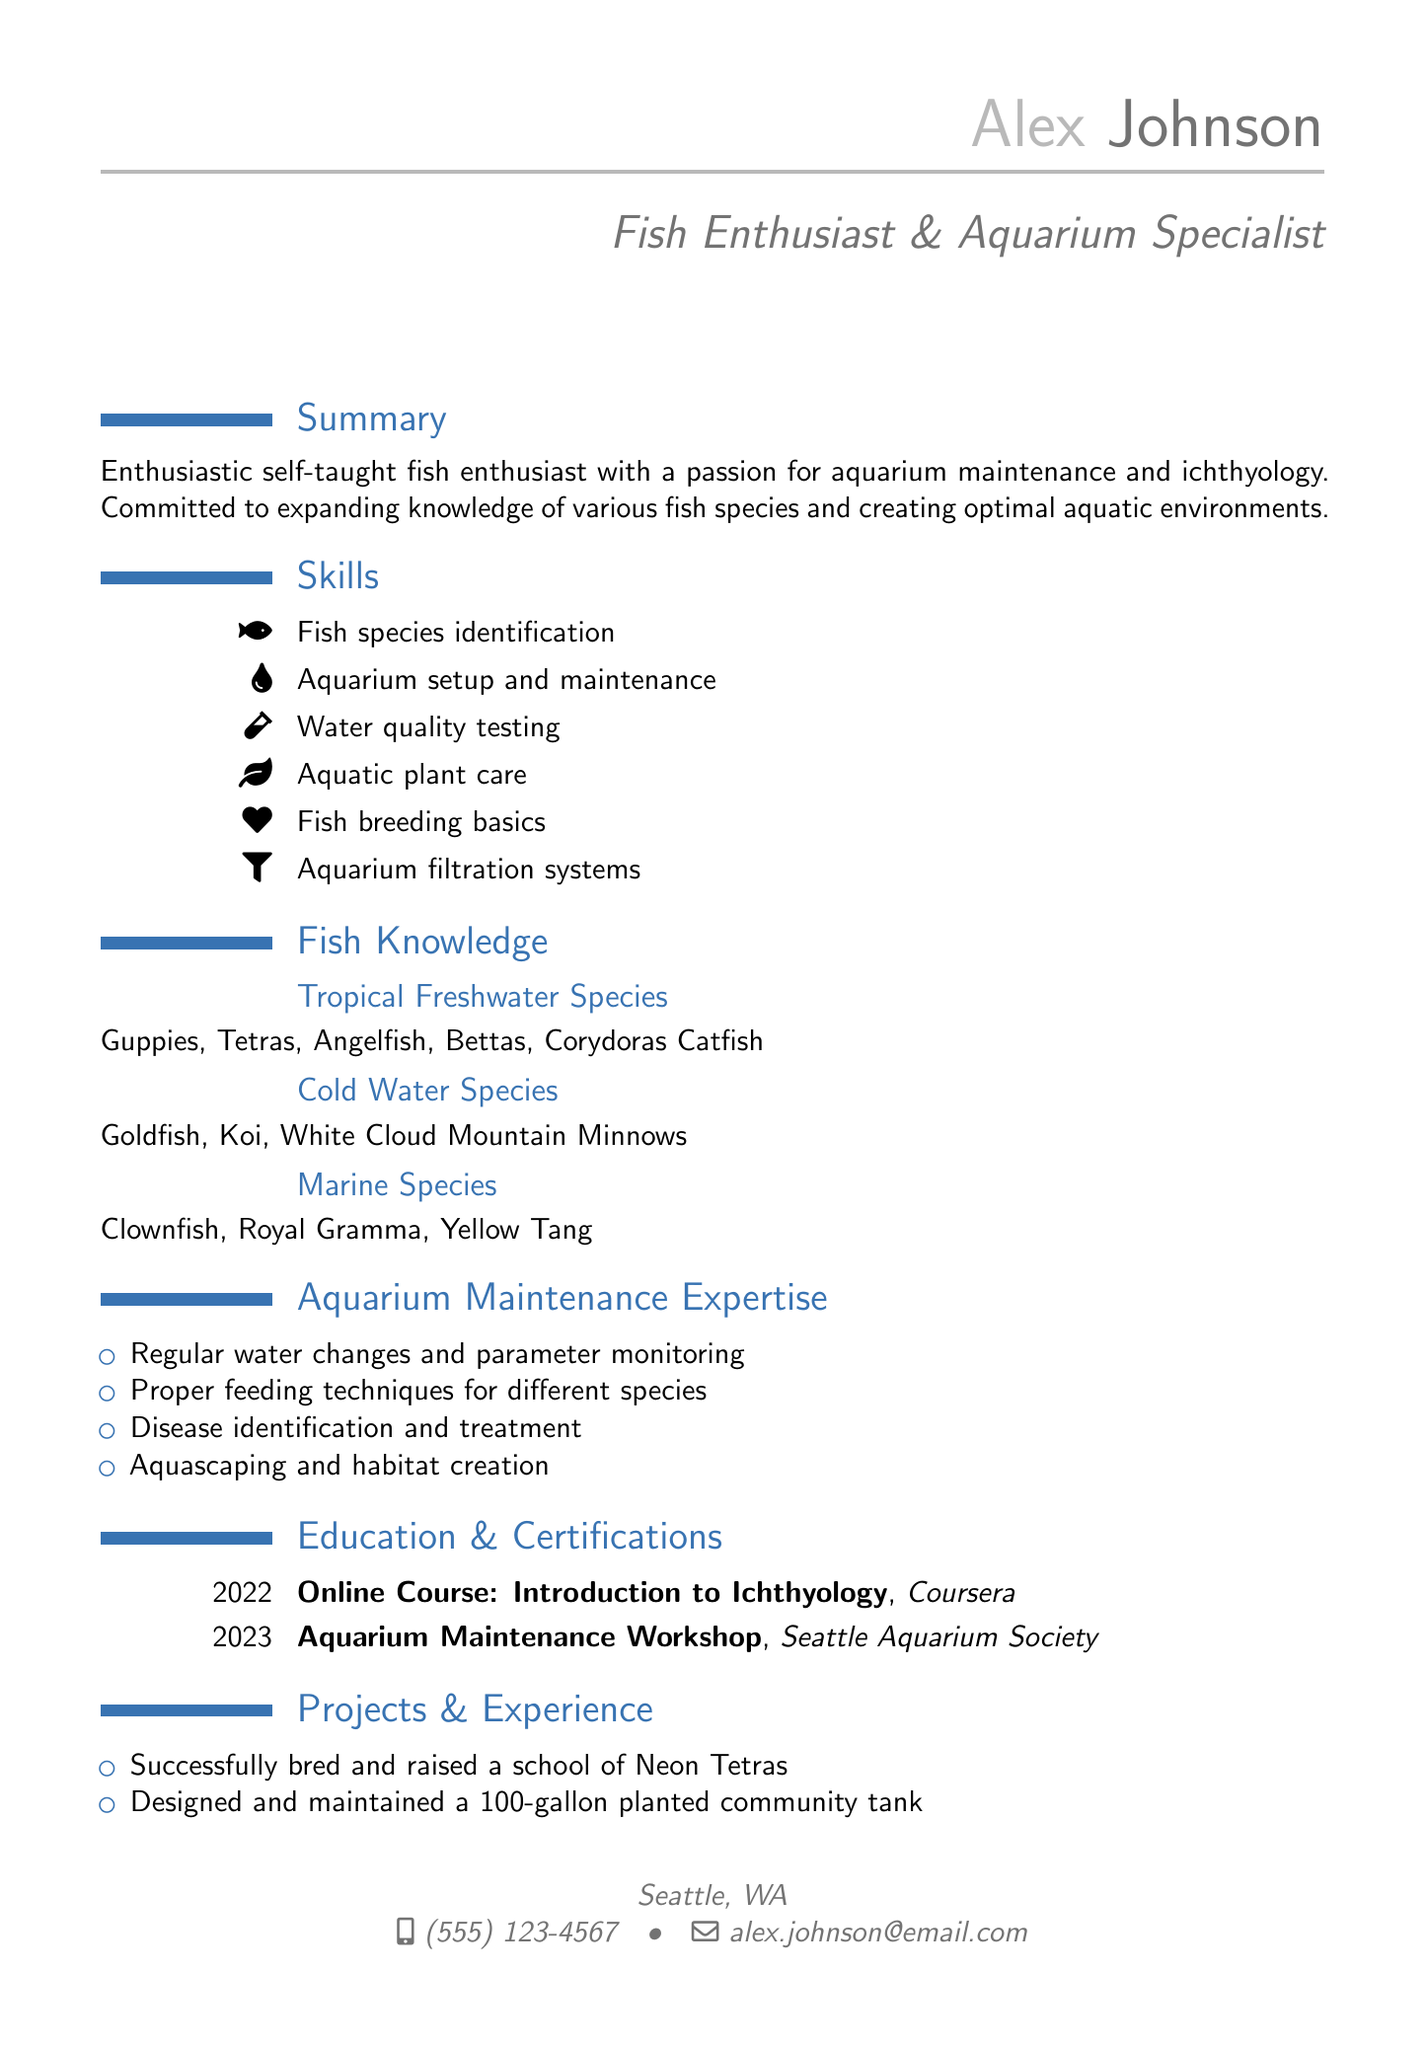what is the name of the fish enthusiast? The document states the name of the fish enthusiast as Alex Johnson.
Answer: Alex Johnson which city does Alex Johnson live in? The location section of the document indicates that Alex Johnson lives in Seattle, WA.
Answer: Seattle, WA what year did Alex complete the online course on ichthyology? The education section specifies that the online course was completed in 2022.
Answer: 2022 how many different categories of fish species are listed? By counting the categories mentioned in the fish knowledge section, there are three: Tropical Freshwater Species, Cold Water Species, and Marine Species.
Answer: 3 what is one example of a tropical freshwater species listed? The fish knowledge section indicates several examples, such as Guppies, Tetras, Angelfish, Bettas, or Corydoras Catfish; any of these would be correct.
Answer: Guppies which organization provided the aquarium maintenance workshop? The document lists the Seattle Aquarium Society as the provider of the aquarium maintenance workshop.
Answer: Seattle Aquarium Society what is one of the aquarium maintenance tasks mentioned? The document specifies multiple tasks, one of which is regular water changes and parameter monitoring.
Answer: Regular water changes who is listed as a reference? The references section of the document identifies Dr. Emily Waters as a reference.
Answer: Dr. Emily Waters how many projects and experiences are listed in the CV? The projects and experience section enumerates three specific examples.
Answer: 3 